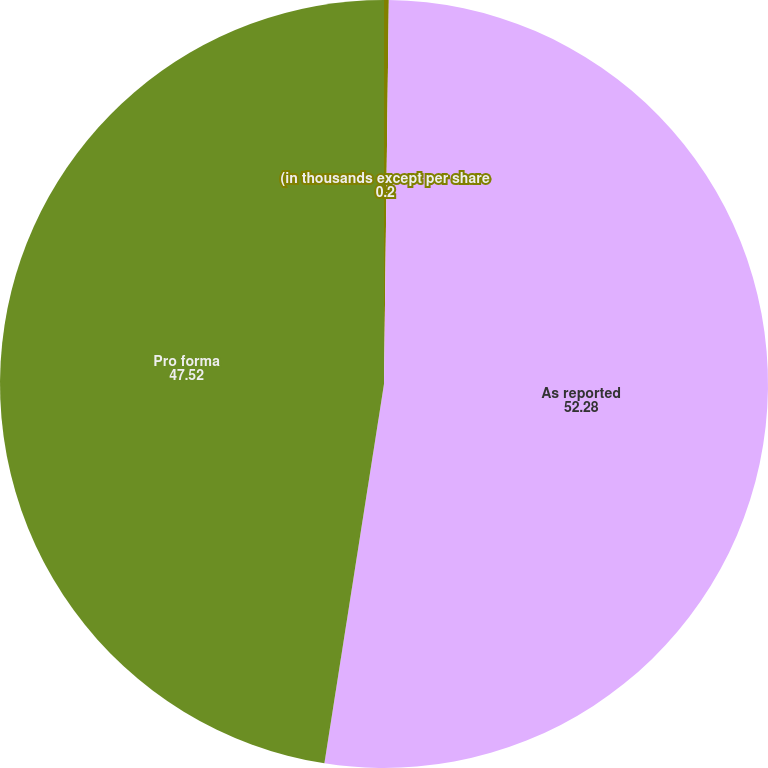Convert chart. <chart><loc_0><loc_0><loc_500><loc_500><pie_chart><fcel>(in thousands except per share<fcel>As reported<fcel>Pro forma<nl><fcel>0.2%<fcel>52.28%<fcel>47.52%<nl></chart> 